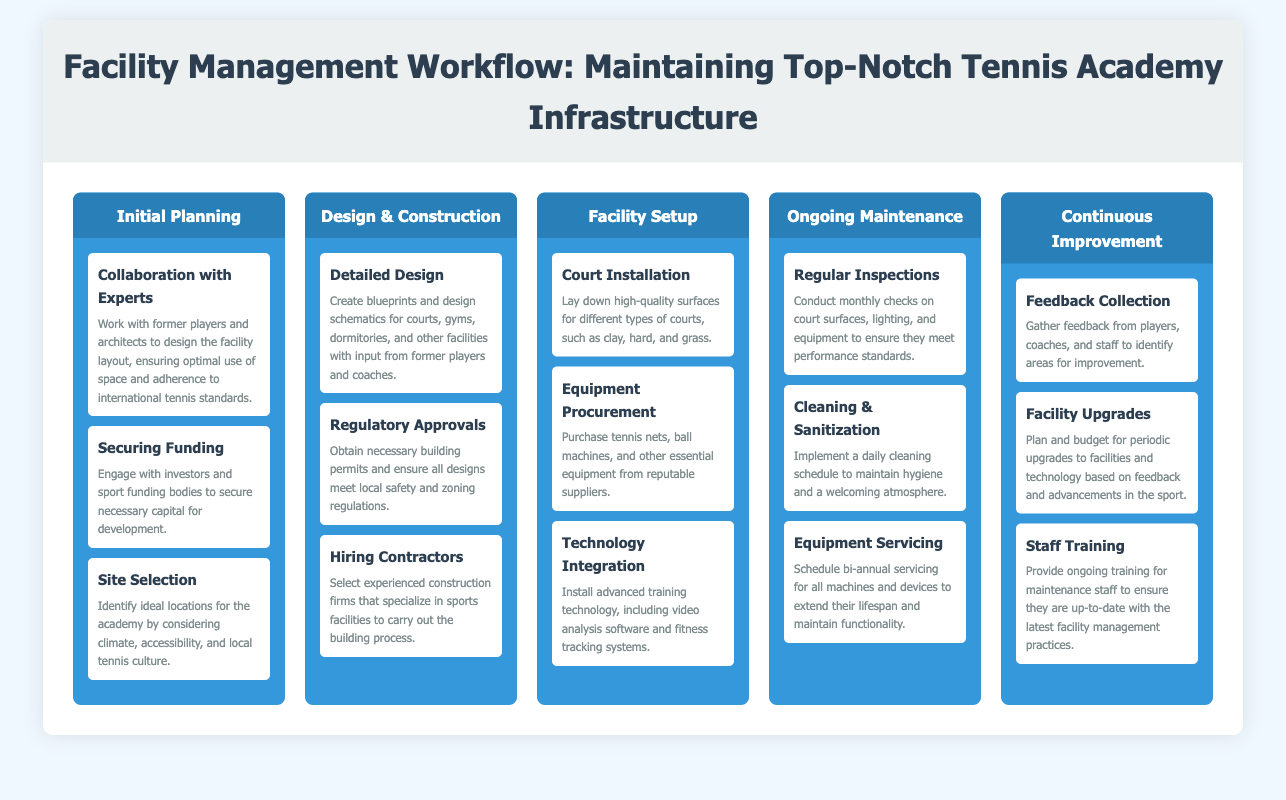What is the first phase of the workflow? The first phase outlined in the workflow is "Initial Planning."
Answer: Initial Planning How many actions are listed under "Facility Setup"? There are three actions listed under "Facility Setup."
Answer: 3 What is one requirement for the "Regulatory Approvals" action? The requirement for this action is to obtain necessary building permits.
Answer: Building permits What type of equipment is mentioned for procurement? Equipment mentioned for procurement includes tennis nets and ball machines.
Answer: Tennis nets, ball machines Which phase includes "Feedback Collection"? The phase that includes "Feedback Collection" is "Continuous Improvement."
Answer: Continuous Improvement How often should regular inspections take place? Regular inspections should be conducted monthly.
Answer: Monthly What is the main purpose of "Staff Training"? The purpose of staff training is to ensure they are up-to-date with the latest facility management practices.
Answer: Up-to-date training What does the "Technology Integration" action involve? This action involves installing advanced training technology.
Answer: Installing advanced training technology Which phase involves "Hiring Contractors"? "Hiring Contractors" is part of the "Design & Construction" phase.
Answer: Design & Construction 